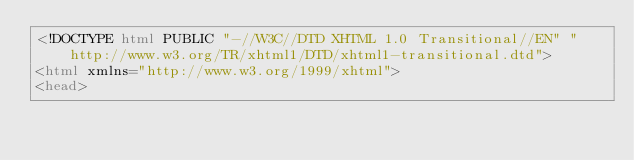Convert code to text. <code><loc_0><loc_0><loc_500><loc_500><_HTML_><!DOCTYPE html PUBLIC "-//W3C//DTD XHTML 1.0 Transitional//EN" "http://www.w3.org/TR/xhtml1/DTD/xhtml1-transitional.dtd">
<html xmlns="http://www.w3.org/1999/xhtml">
<head></code> 